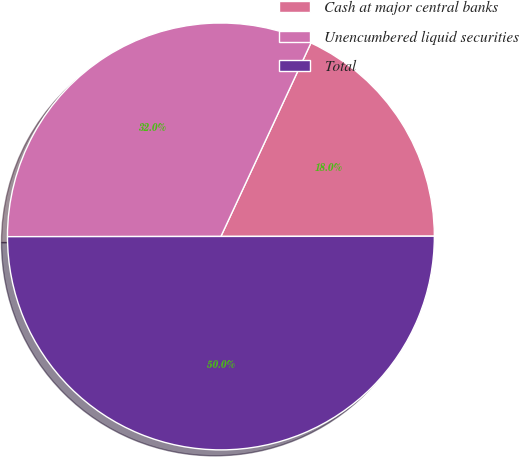Convert chart to OTSL. <chart><loc_0><loc_0><loc_500><loc_500><pie_chart><fcel>Cash at major central banks<fcel>Unencumbered liquid securities<fcel>Total<nl><fcel>18.05%<fcel>31.95%<fcel>50.0%<nl></chart> 